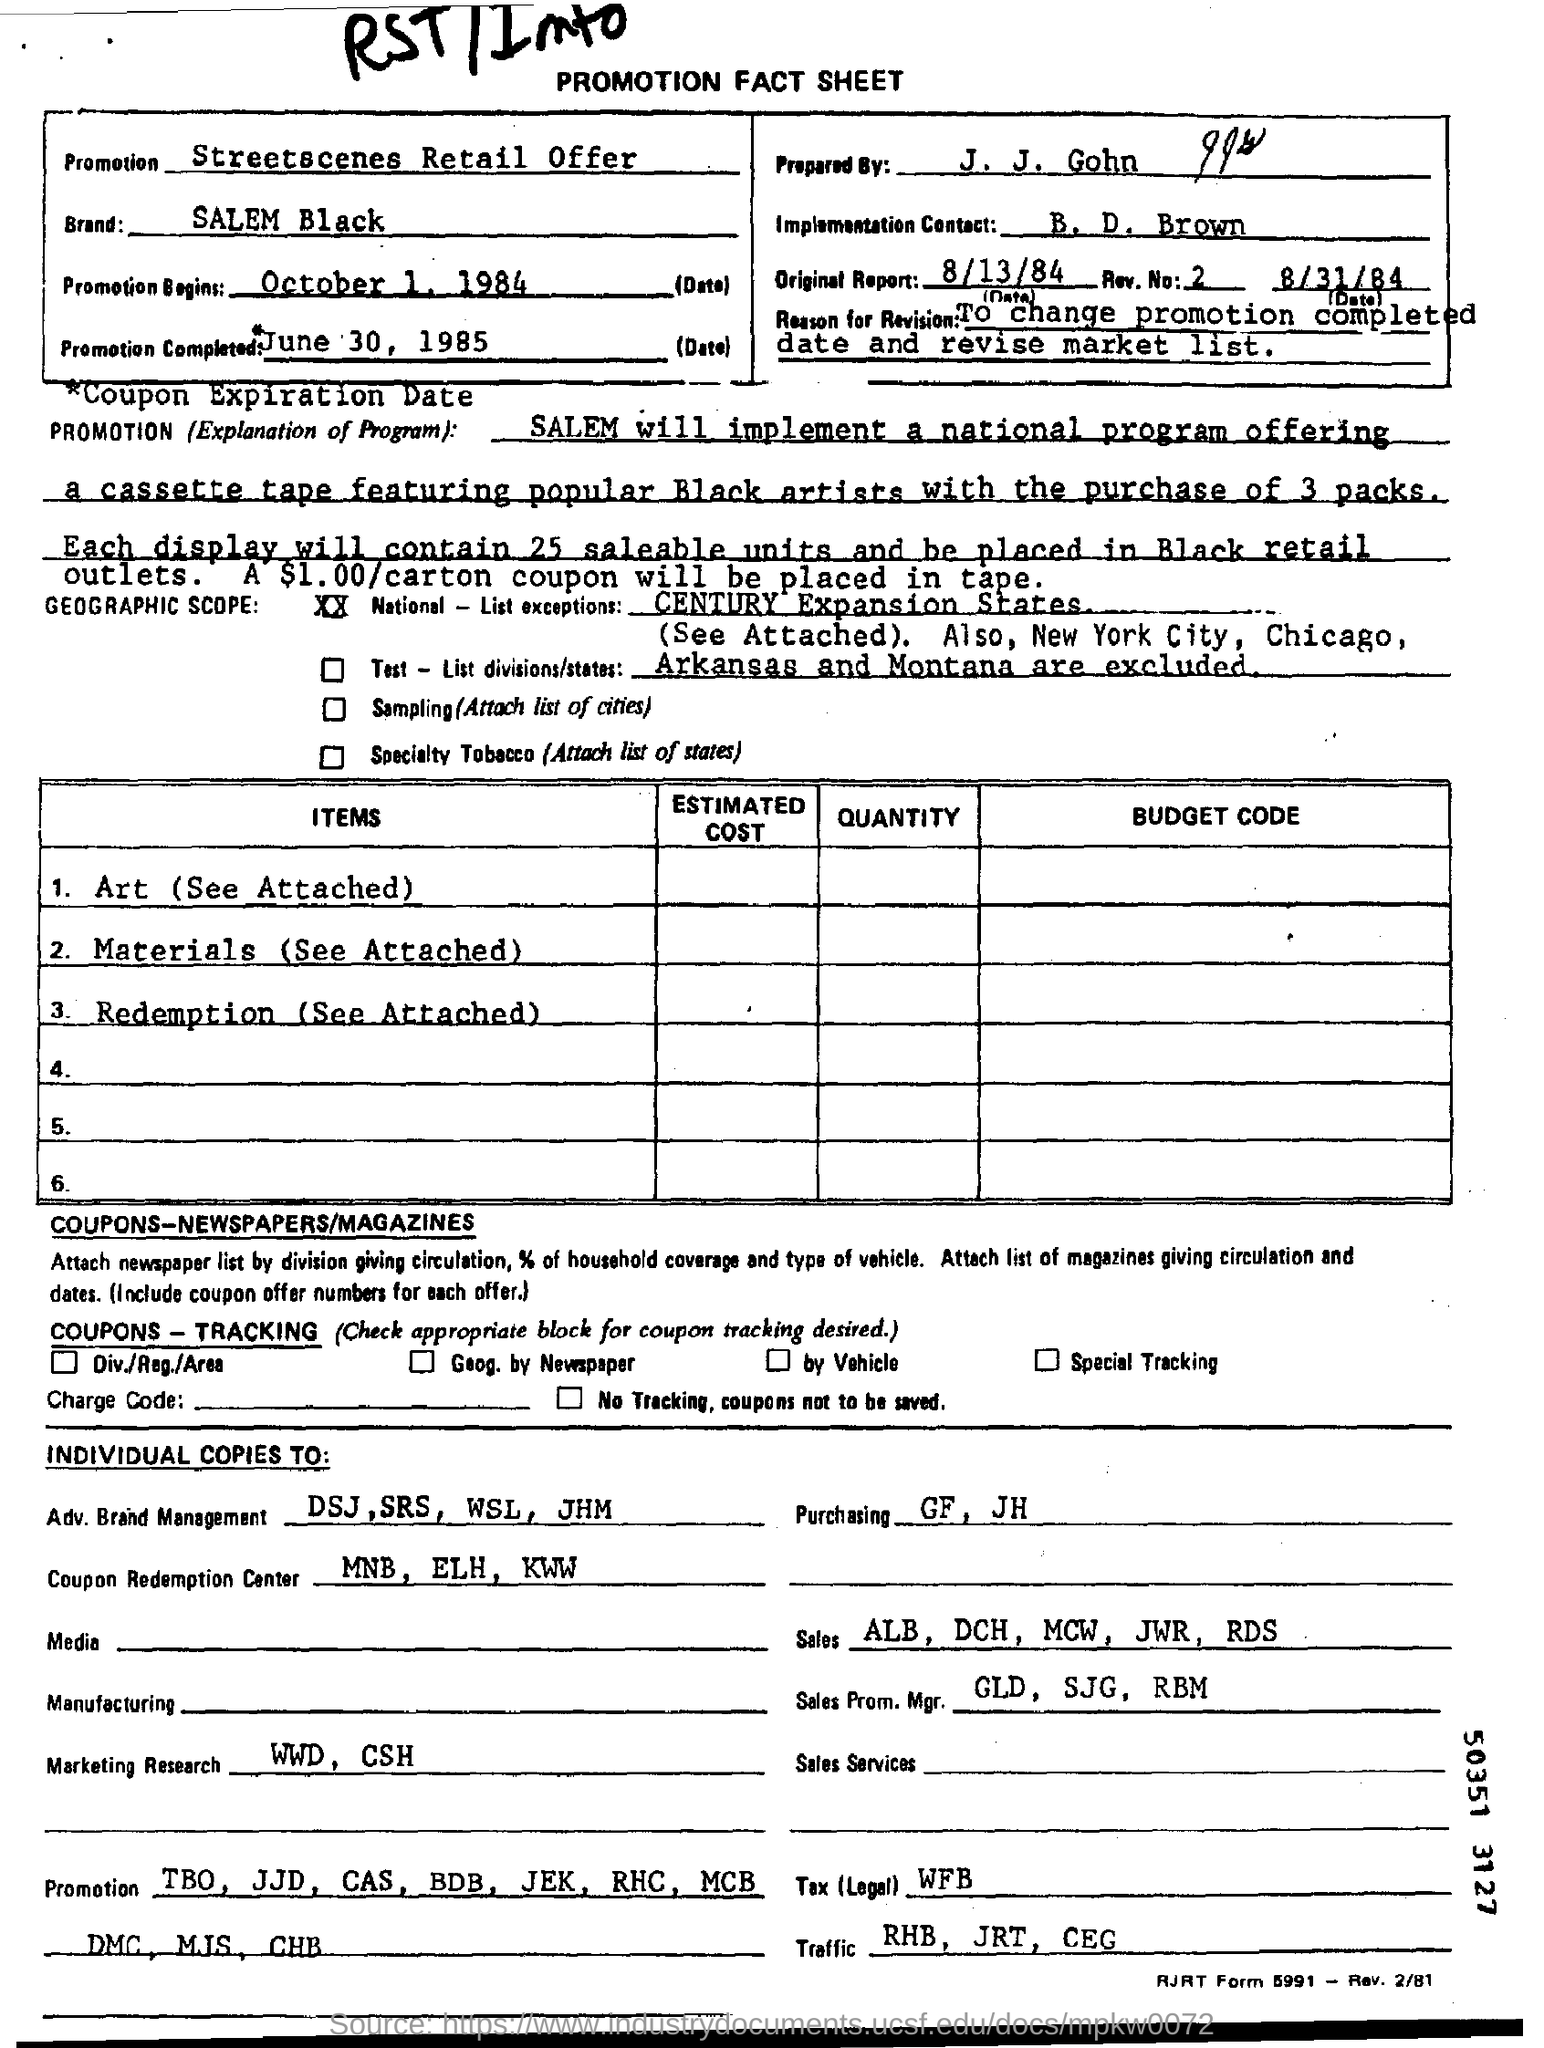List a handful of essential elements in this visual. The promotion completed date is June 30, 1985. The letterhead contains a promotion fact sheet. The information written in the Promotion field is 'Streetscenes Retail Offer.' The purchasing field contains the entries 'GF' and 'JH'. 